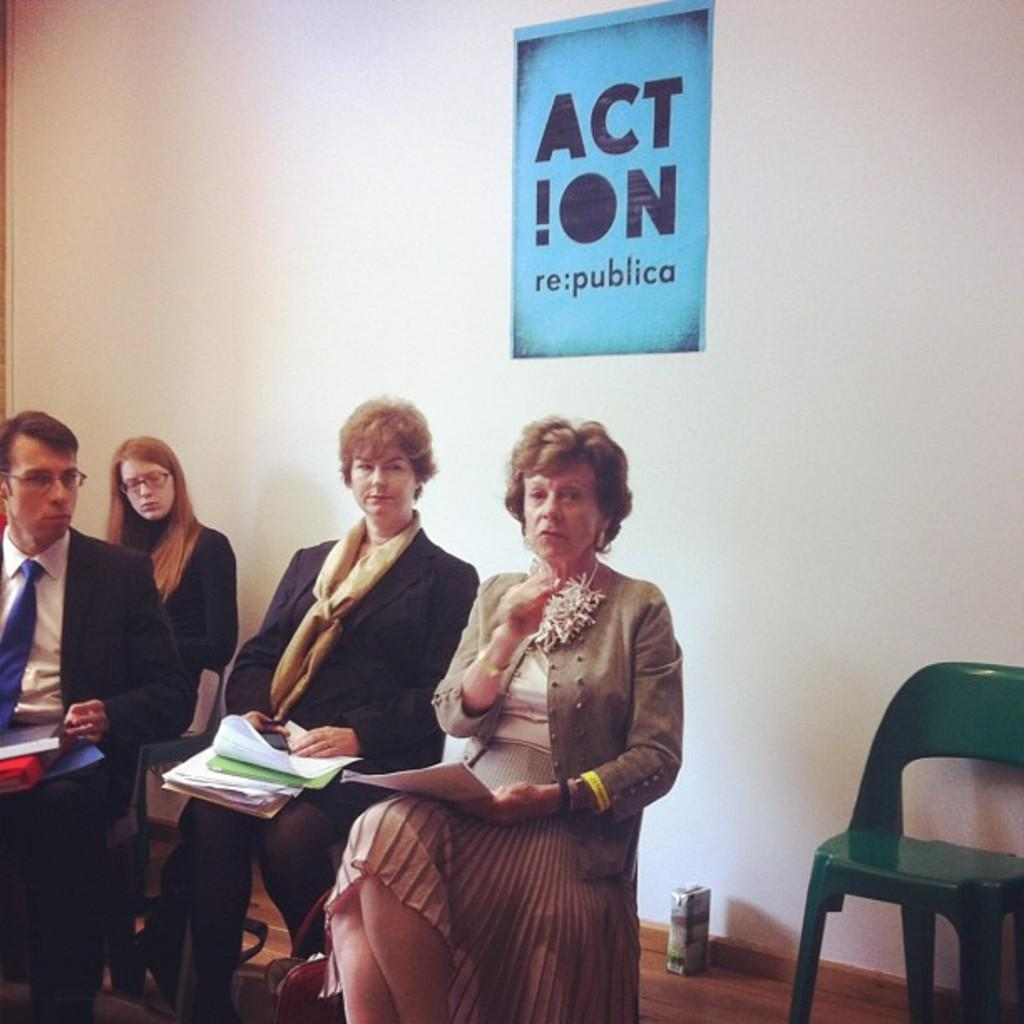What are the people in the image doing? The people in the image are sitting on chairs. What can be seen behind the people? There is a wall visible in the image. What type of rail can be seen in the wilderness area of the image? There is no rail or wilderness area present in the image; it only shows people sitting on chairs with a wall visible in the background. 